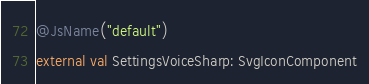Convert code to text. <code><loc_0><loc_0><loc_500><loc_500><_Kotlin_>
@JsName("default")
external val SettingsVoiceSharp: SvgIconComponent
</code> 